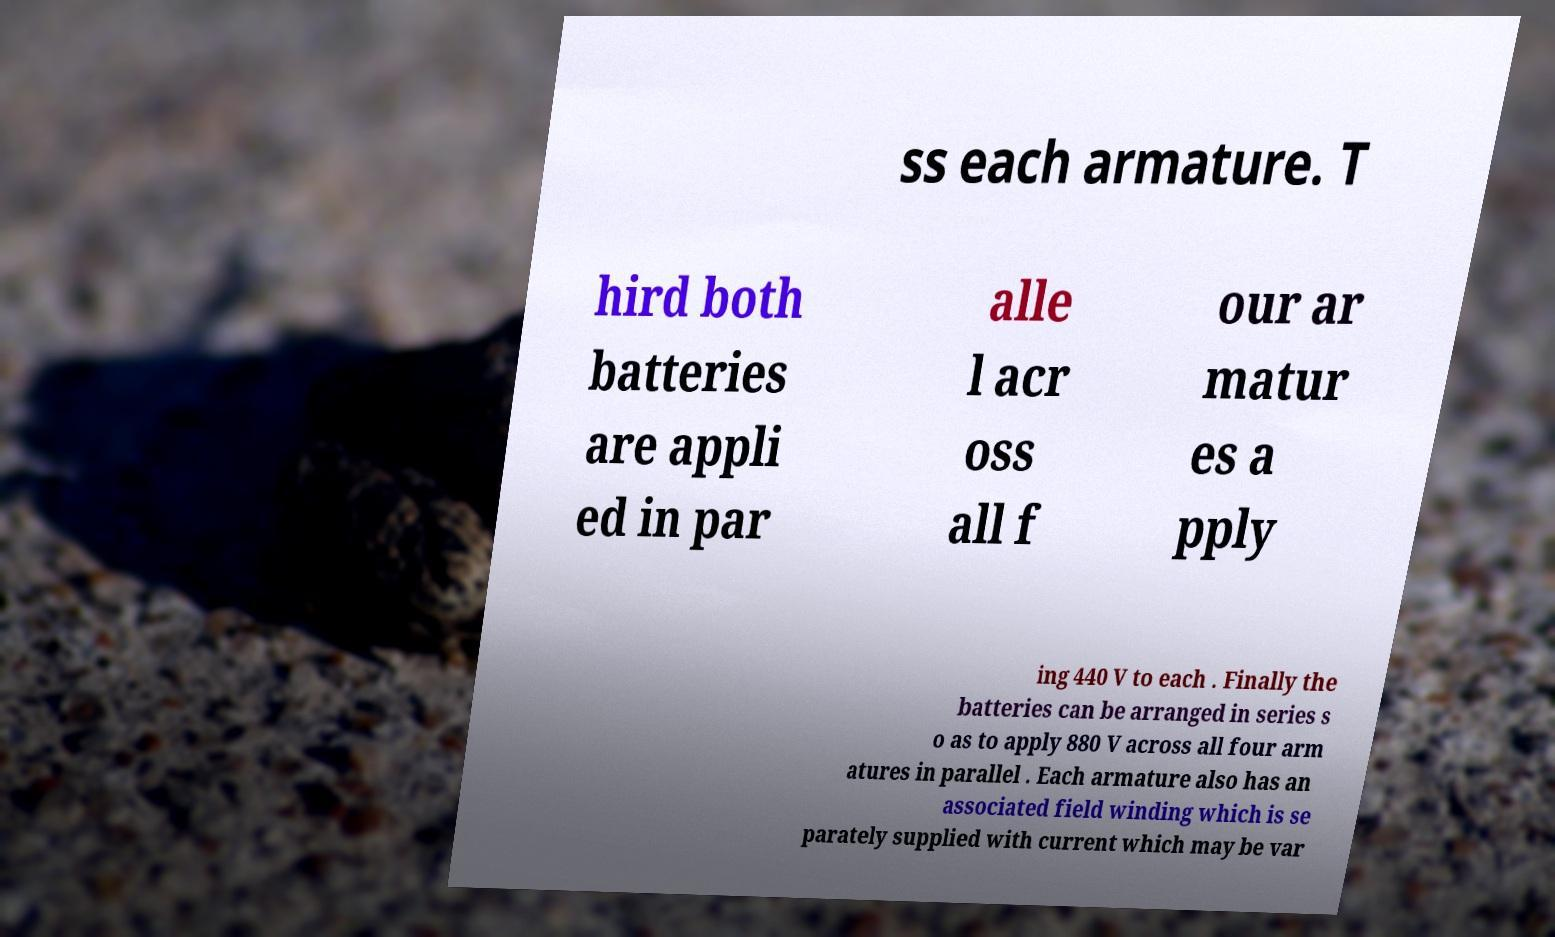For documentation purposes, I need the text within this image transcribed. Could you provide that? ss each armature. T hird both batteries are appli ed in par alle l acr oss all f our ar matur es a pply ing 440 V to each . Finally the batteries can be arranged in series s o as to apply 880 V across all four arm atures in parallel . Each armature also has an associated field winding which is se parately supplied with current which may be var 